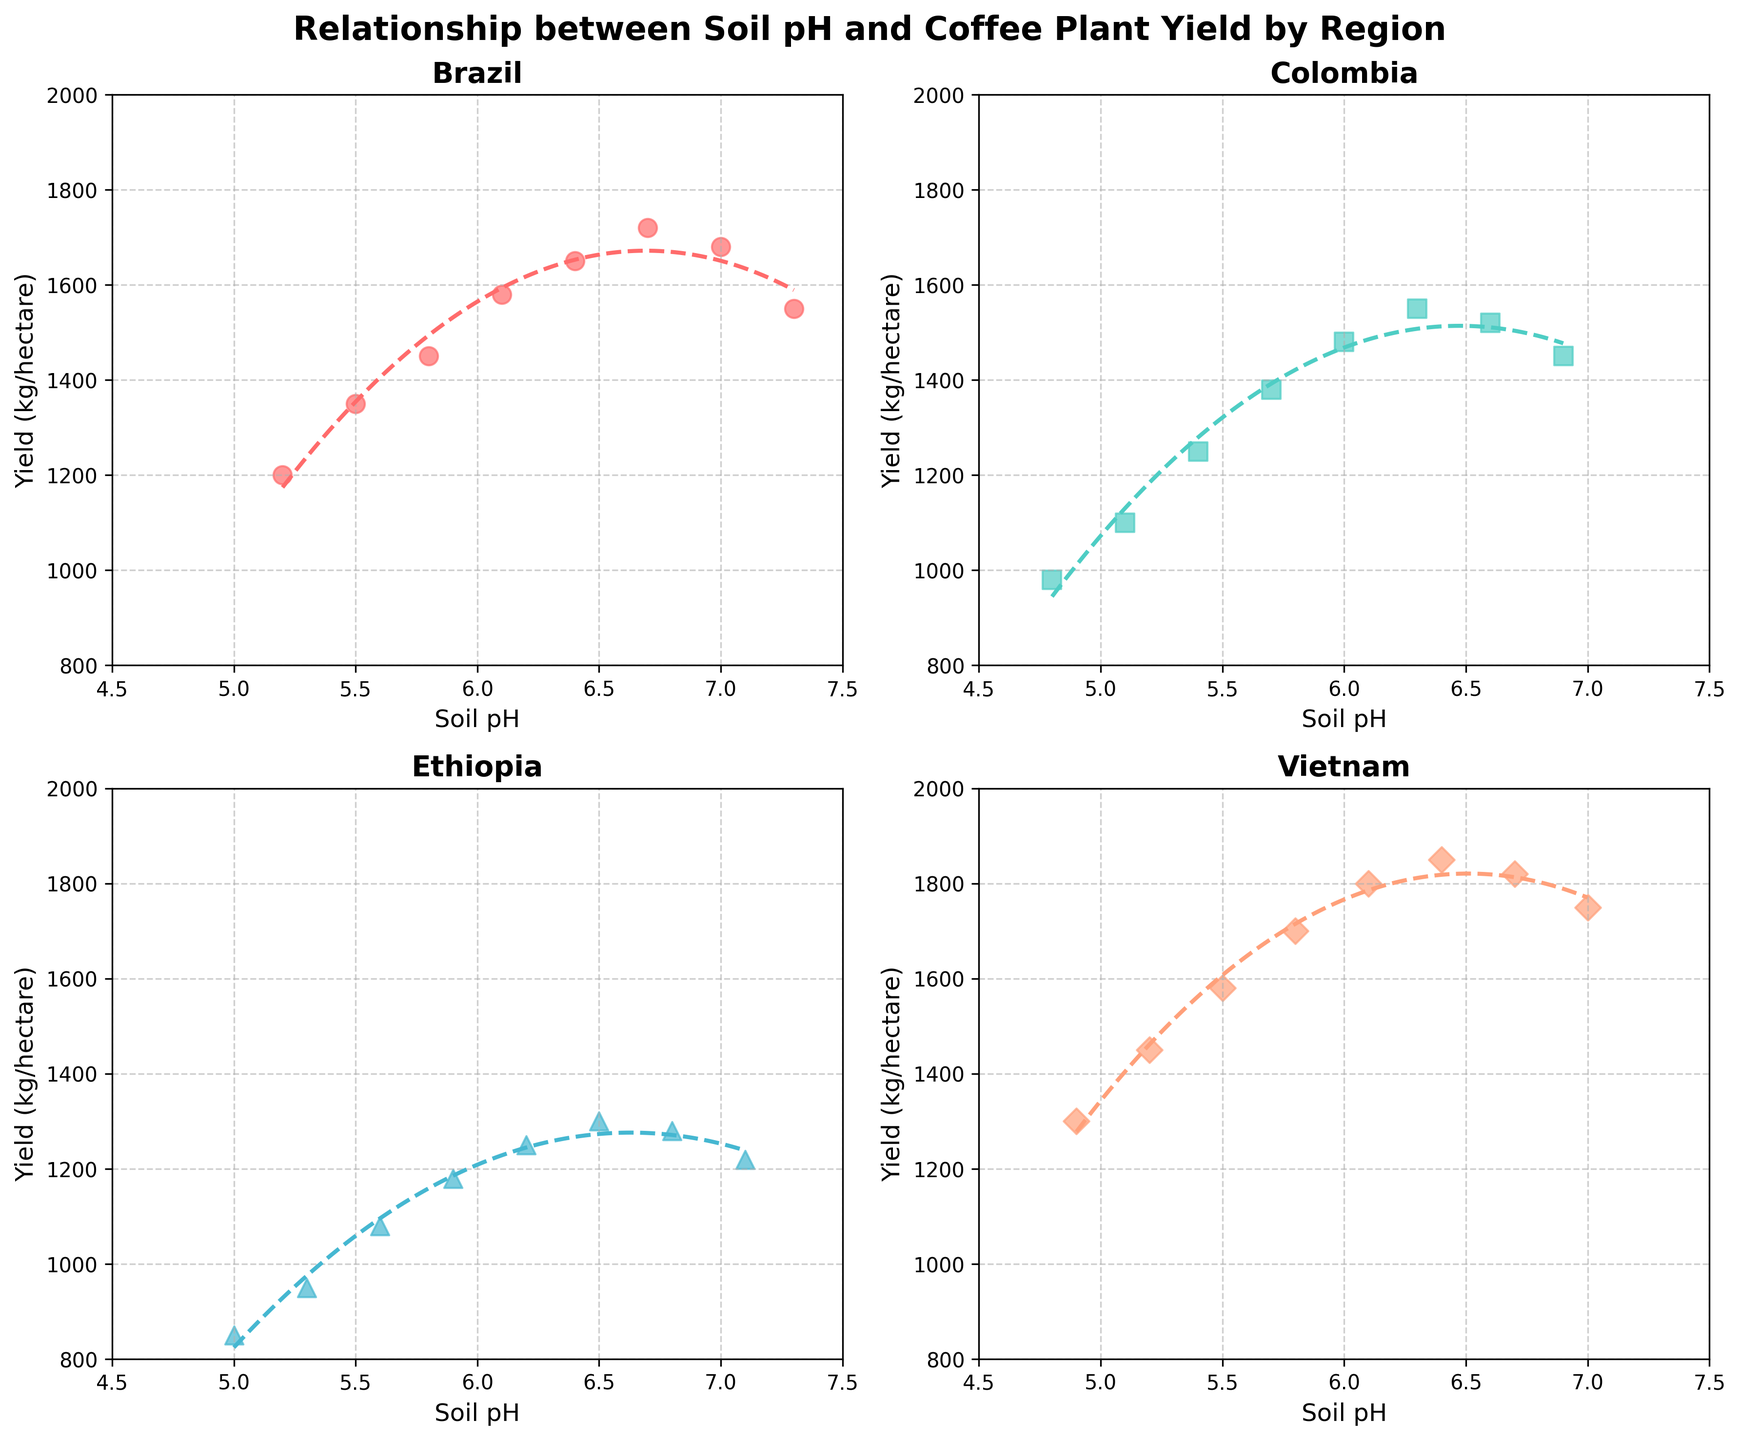What region shows the maximum yield at any soil pH level? By inspecting the different scatter plots and the maximum point in each, Vietnam shows a yield of 1850 kg/hectare at a soil pH of 6.4, which is the highest yield among all regions.
Answer: Vietnam Which region appears to have the most significant decrease in yield beyond a specific pH level? In the scatter plots, Brazil and Colombia show a noticeable decrease in yield beyond a pH of 7.0 and 6.6, respectively. Among these, the yield drop in Brazil (from 1720 to 1550) is larger compared to Colombia.
Answer: Brazil What is the optimum pH range for yield in Ethiopia? By looking at the scatter plot and the fitted polynomial curve for Ethiopia, the yield peaks around a soil pH of 6.2 to 6.5.
Answer: 6.2 to 6.5 In Brazil, how much does the yield increase from a soil pH of 5.2 to 6.4? In Brazil's subplot, the yield increases from 1200 kg/hectare at a pH of 5.2 to 1650 kg/hectare at a pH of 6.4. The increase is 1650 - 1200 = 450 kg/hectare.
Answer: 450 kg/hectare Compare the yield trends of Vietnam and Colombia. Which region maintains higher yields overall within their optimum pH range? Inspecting both scatter plots and fitted curves, Vietnam maintains higher yields (ranging from 1300 to 1800 kg/hectare) within its optimum pH range (5.2 to 6.7) compared to Colombia (ranging from 980 to 1550 kg/hectare) within its optimum pH range (4.8 to 6.3).
Answer: Vietnam Which region has the least variation in yield in relation to soil pH? Ethiopia shows the least variation in yield with a more stable range between 850 to 1300 kg/hectare across the pH spectrum compared to other regions.
Answer: Ethiopia At a pH of 6.0, which region has the highest yield and what is it? Inspecting the scatter plots for the specific pH of 6.0, Vietnam has the highest yield of 1800 kg/hectare.
Answer: Vietnam, 1800 kg/hectare In Colombia, by how much does the yield decrease from a pH of 6.6 to 6.9? In Colombia's subplot, the yield decreases from 1520 kg/hectare at a pH of 6.6 to 1450 kg/hectare at a pH of 6.9, resulting in a decrease of 1520 - 1450 = 70 kg/hectare.
Answer: 70 kg/hectare Comparing the fitted polynomial curves, which region's curve shows the sharpest peak indicating the optimum soil pH for yield? Vietnam's polynomial curve shows the sharpest peak around a pH of 6.4, indicating a more narrowly defined optimum soil pH range for maximum yield.
Answer: Vietnam 